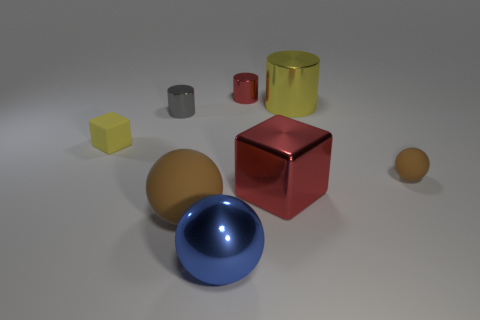Do the tiny rubber cube and the cylinder that is behind the big yellow shiny cylinder have the same color?
Provide a short and direct response. No. There is a big sphere on the left side of the blue thing; what number of large blue spheres are behind it?
Provide a short and direct response. 0. There is a shiny thing that is in front of the small block and behind the large blue sphere; what is its size?
Ensure brevity in your answer.  Large. Is there a yellow shiny object that has the same size as the blue metal object?
Offer a terse response. Yes. Is the number of brown rubber spheres that are in front of the small yellow block greater than the number of tiny gray shiny cylinders in front of the gray object?
Provide a short and direct response. Yes. Does the large cylinder have the same material as the small cylinder that is on the left side of the small red shiny cylinder?
Provide a short and direct response. Yes. How many brown spheres are to the left of the sphere that is on the right side of the tiny metallic cylinder that is to the right of the gray metal cylinder?
Your response must be concise. 1. There is a blue shiny thing; does it have the same shape as the tiny matte thing right of the yellow rubber cube?
Your answer should be very brief. Yes. The big thing that is behind the large blue object and left of the red cylinder is what color?
Ensure brevity in your answer.  Brown. What is the yellow object that is left of the block to the right of the cube behind the small brown sphere made of?
Offer a terse response. Rubber. 